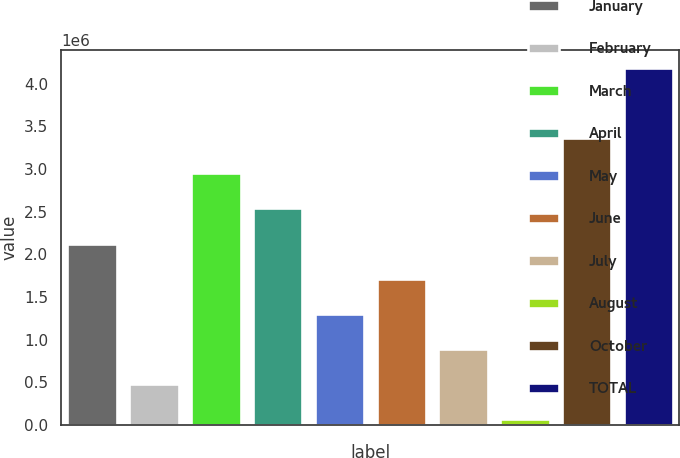<chart> <loc_0><loc_0><loc_500><loc_500><bar_chart><fcel>January<fcel>February<fcel>March<fcel>April<fcel>May<fcel>June<fcel>July<fcel>August<fcel>October<fcel>TOTAL<nl><fcel>2.12616e+06<fcel>479181<fcel>2.94965e+06<fcel>2.53791e+06<fcel>1.30267e+06<fcel>1.71442e+06<fcel>890927<fcel>67436<fcel>3.3614e+06<fcel>4.18489e+06<nl></chart> 